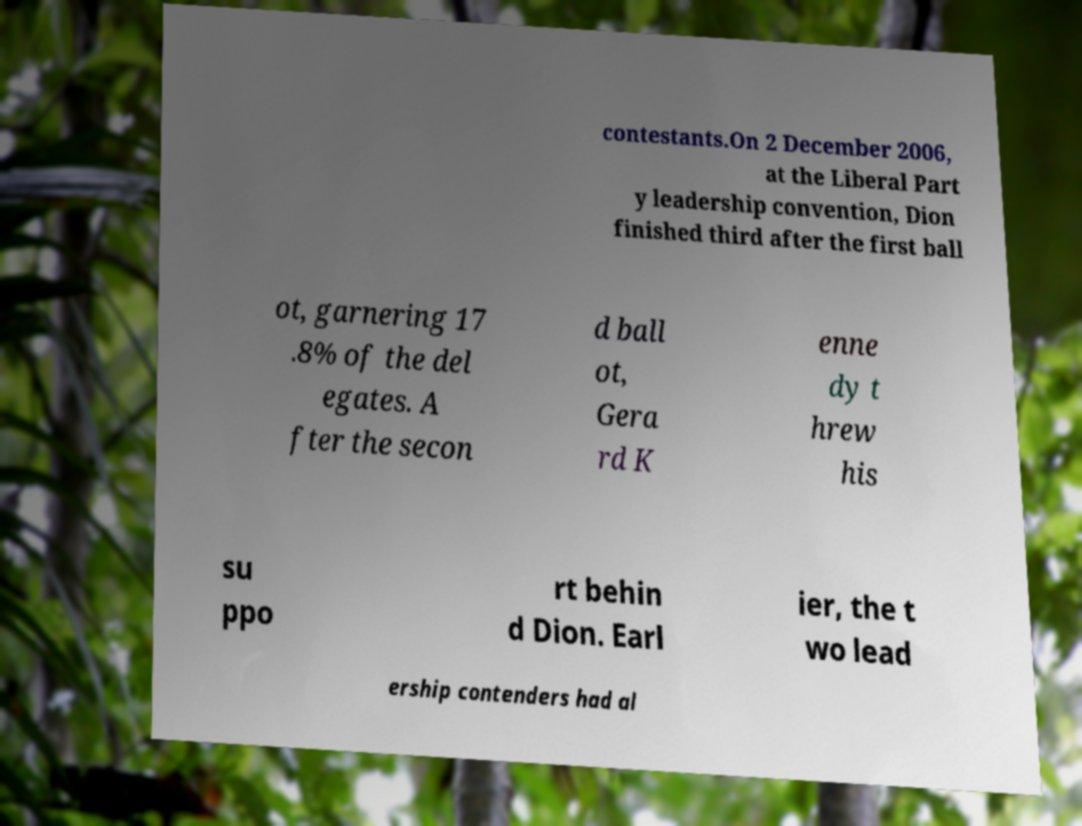Can you read and provide the text displayed in the image?This photo seems to have some interesting text. Can you extract and type it out for me? contestants.On 2 December 2006, at the Liberal Part y leadership convention, Dion finished third after the first ball ot, garnering 17 .8% of the del egates. A fter the secon d ball ot, Gera rd K enne dy t hrew his su ppo rt behin d Dion. Earl ier, the t wo lead ership contenders had al 